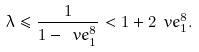Convert formula to latex. <formula><loc_0><loc_0><loc_500><loc_500>\lambda \leq \frac { 1 } { 1 - \ v e _ { 1 } ^ { 8 } } < 1 + 2 \ v e _ { 1 } ^ { 8 } .</formula> 